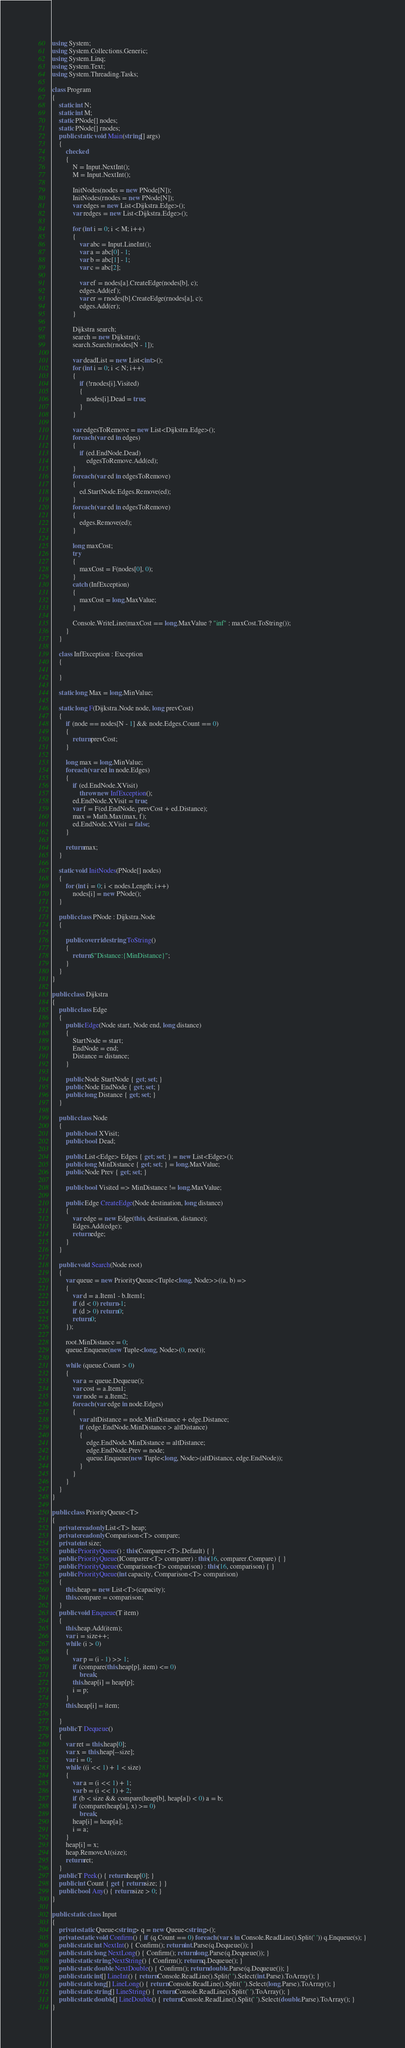Convert code to text. <code><loc_0><loc_0><loc_500><loc_500><_C#_>using System;
using System.Collections.Generic;
using System.Linq;
using System.Text;
using System.Threading.Tasks;

class Program
{
    static int N;
    static int M;
    static PNode[] nodes;
    static PNode[] rnodes;
    public static void Main(string[] args)
    {
        checked
        {
            N = Input.NextInt();
            M = Input.NextInt();

            InitNodes(nodes = new PNode[N]);
            InitNodes(rnodes = new PNode[N]);
            var edges = new List<Dijkstra.Edge>();
            var redges = new List<Dijkstra.Edge>();

            for (int i = 0; i < M; i++)
            {
                var abc = Input.LineInt();
                var a = abc[0] - 1;
                var b = abc[1] - 1;
                var c = abc[2];

                var ef = nodes[a].CreateEdge(nodes[b], c);
                edges.Add(ef);
                var er = rnodes[b].CreateEdge(rnodes[a], c);
                edges.Add(er);
            }

            Dijkstra search;
            search = new Dijkstra();
            search.Search(rnodes[N - 1]);

            var deadList = new List<int>();
            for (int i = 0; i < N; i++)
            {
                if (!rnodes[i].Visited)
                {
                    nodes[i].Dead = true;
                }
            }

            var edgesToRemove = new List<Dijkstra.Edge>();
            foreach (var ed in edges)
            {
                if (ed.EndNode.Dead)
                    edgesToRemove.Add(ed);
            }
            foreach (var ed in edgesToRemove)
            {
                ed.StartNode.Edges.Remove(ed);
            }
            foreach (var ed in edgesToRemove)
            {
                edges.Remove(ed);
            }

            long maxCost;
            try
            {
                maxCost = F(nodes[0], 0);
            }
            catch (InfException)
            {
                maxCost = long.MaxValue;
            }

            Console.WriteLine(maxCost == long.MaxValue ? "inf" : maxCost.ToString());
        }
    }

    class InfException : Exception
    {

    }

    static long Max = long.MinValue;

    static long F(Dijkstra.Node node, long prevCost)
    {
        if (node == nodes[N - 1] && node.Edges.Count == 0)
        {
            return prevCost;
        }

        long max = long.MinValue;
        foreach (var ed in node.Edges)
        {
            if (ed.EndNode.XVisit)
                throw new InfException();
            ed.EndNode.XVisit = true;
            var f = F(ed.EndNode, prevCost + ed.Distance);
            max = Math.Max(max, f);
            ed.EndNode.XVisit = false;
        }

        return max;
    }

    static void InitNodes(PNode[] nodes)
    {
        for (int i = 0; i < nodes.Length; i++)
            nodes[i] = new PNode();
    }

    public class PNode : Dijkstra.Node
    {

        public override string ToString()
        {
            return $"Distance:{MinDistance}";
        }
    }
}

public class Dijkstra
{
    public class Edge
    {
        public Edge(Node start, Node end, long distance)
        {
            StartNode = start;
            EndNode = end;
            Distance = distance;
        }

        public Node StartNode { get; set; }
        public Node EndNode { get; set; }
        public long Distance { get; set; }
    }

    public class Node
    {
        public bool XVisit;
        public bool Dead;

        public List<Edge> Edges { get; set; } = new List<Edge>();
        public long MinDistance { get; set; } = long.MaxValue;
        public Node Prev { get; set; }

        public bool Visited => MinDistance != long.MaxValue;

        public Edge CreateEdge(Node destination, long distance)
        {
            var edge = new Edge(this, destination, distance);
            Edges.Add(edge);
            return edge;
        }
    }

    public void Search(Node root)
    {
        var queue = new PriorityQueue<Tuple<long, Node>>((a, b) =>
        {
            var d = a.Item1 - b.Item1;
            if (d < 0) return -1;
            if (d > 0) return 0;
            return 0;
        });

        root.MinDistance = 0;
        queue.Enqueue(new Tuple<long, Node>(0, root));

        while (queue.Count > 0)
        {
            var a = queue.Dequeue();
            var cost = a.Item1;
            var node = a.Item2;
            foreach (var edge in node.Edges)
            {
                var altDistance = node.MinDistance + edge.Distance;
                if (edge.EndNode.MinDistance > altDistance)
                {
                    edge.EndNode.MinDistance = altDistance;
                    edge.EndNode.Prev = node;
                    queue.Enqueue(new Tuple<long, Node>(altDistance, edge.EndNode));
                }
            }
        }
    }
}

public class PriorityQueue<T>
{
    private readonly List<T> heap;
    private readonly Comparison<T> compare;
    private int size;
    public PriorityQueue() : this(Comparer<T>.Default) { }
    public PriorityQueue(IComparer<T> comparer) : this(16, comparer.Compare) { }
    public PriorityQueue(Comparison<T> comparison) : this(16, comparison) { }
    public PriorityQueue(int capacity, Comparison<T> comparison)
    {
        this.heap = new List<T>(capacity);
        this.compare = comparison;
    }
    public void Enqueue(T item)
    {
        this.heap.Add(item);
        var i = size++;
        while (i > 0)
        {
            var p = (i - 1) >> 1;
            if (compare(this.heap[p], item) <= 0)
                break;
            this.heap[i] = heap[p];
            i = p;
        }
        this.heap[i] = item;

    }
    public T Dequeue()
    {
        var ret = this.heap[0];
        var x = this.heap[--size];
        var i = 0;
        while ((i << 1) + 1 < size)
        {
            var a = (i << 1) + 1;
            var b = (i << 1) + 2;
            if (b < size && compare(heap[b], heap[a]) < 0) a = b;
            if (compare(heap[a], x) >= 0)
                break;
            heap[i] = heap[a];
            i = a;
        }
        heap[i] = x;
        heap.RemoveAt(size);
        return ret;
    }
    public T Peek() { return heap[0]; }
    public int Count { get { return size; } }
    public bool Any() { return size > 0; }
}

public static class Input
{
    private static Queue<string> q = new Queue<string>();
    private static void Confirm() { if (q.Count == 0) foreach (var s in Console.ReadLine().Split(' ')) q.Enqueue(s); }
    public static int NextInt() { Confirm(); return int.Parse(q.Dequeue()); }
    public static long NextLong() { Confirm(); return long.Parse(q.Dequeue()); }
    public static string NextString() { Confirm(); return q.Dequeue(); }
    public static double NextDouble() { Confirm(); return double.Parse(q.Dequeue()); }
    public static int[] LineInt() { return Console.ReadLine().Split(' ').Select(int.Parse).ToArray(); }
    public static long[] LineLong() { return Console.ReadLine().Split(' ').Select(long.Parse).ToArray(); }
    public static string[] LineString() { return Console.ReadLine().Split(' ').ToArray(); }
    public static double[] LineDouble() { return Console.ReadLine().Split(' ').Select(double.Parse).ToArray(); }
}
</code> 